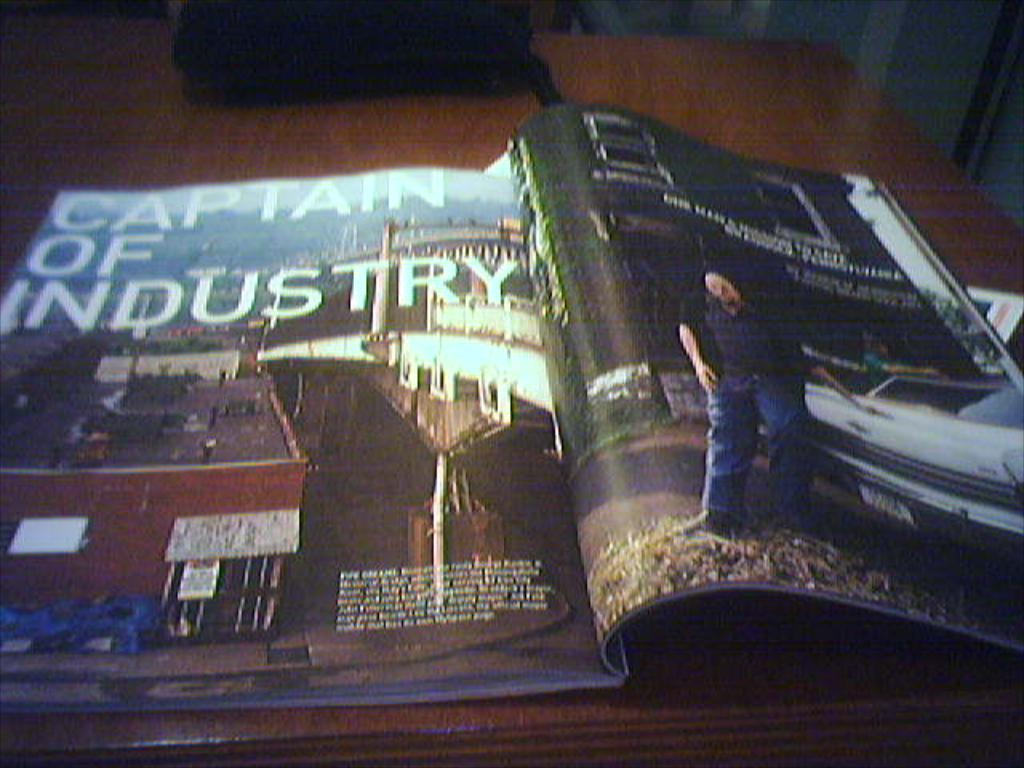<image>
Present a compact description of the photo's key features. Open magazine on the story "Captain Of Industry" showing a man by his car. 